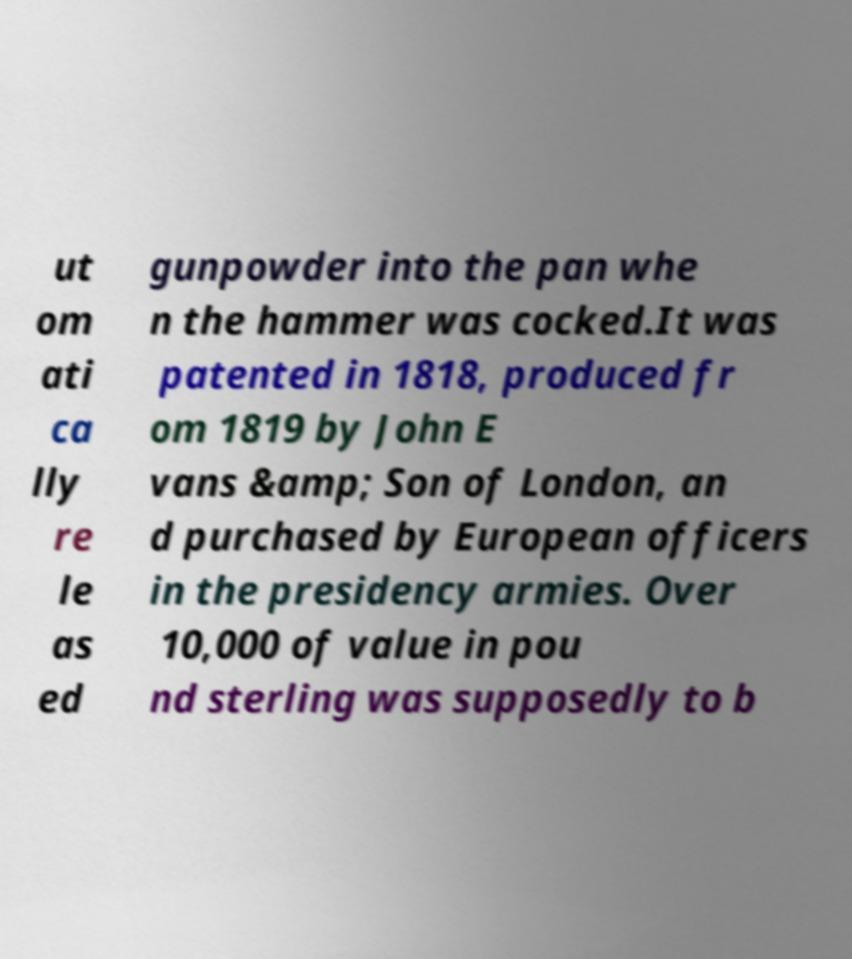Could you assist in decoding the text presented in this image and type it out clearly? ut om ati ca lly re le as ed gunpowder into the pan whe n the hammer was cocked.It was patented in 1818, produced fr om 1819 by John E vans &amp; Son of London, an d purchased by European officers in the presidency armies. Over 10,000 of value in pou nd sterling was supposedly to b 